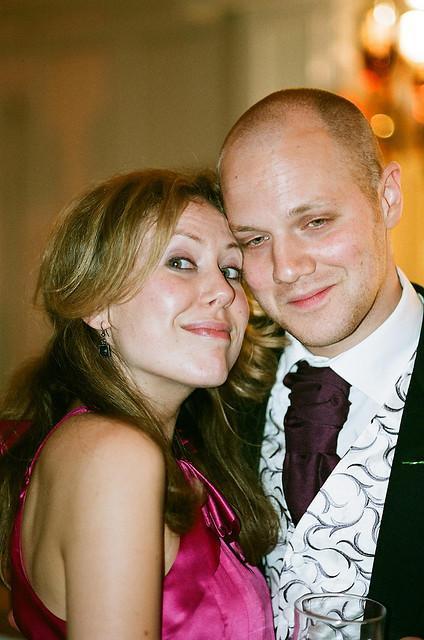How many adults are in the photo?
Give a very brief answer. 2. How many cups are there?
Give a very brief answer. 1. How many people can you see?
Give a very brief answer. 2. How many giraffes are there?
Give a very brief answer. 0. 